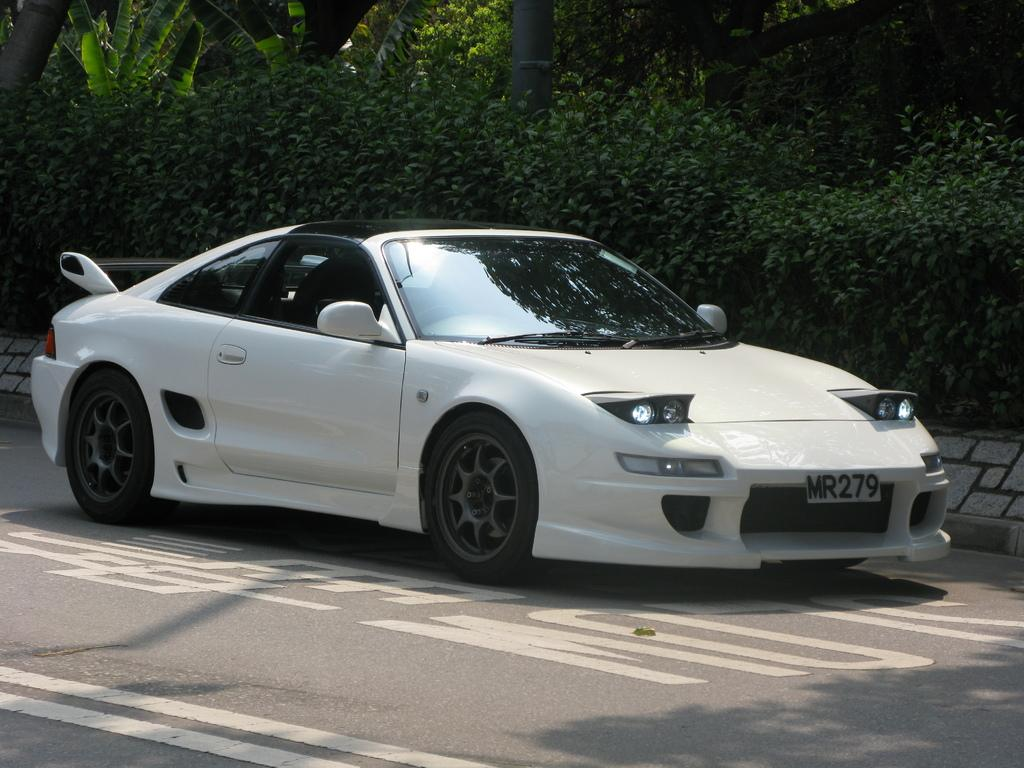What is located at the bottom of the image? There is a road at the bottom of the image. What can be seen in the foreground of the image? There is a vehicle in the foreground of the image. What type of vegetation is visible in the background of the image? There are plants and trees in the background of the image. Where is the stove located in the image? There is no stove present in the image. Can you describe the grandmother's outfit in the image? There is no grandmother present in the image. 